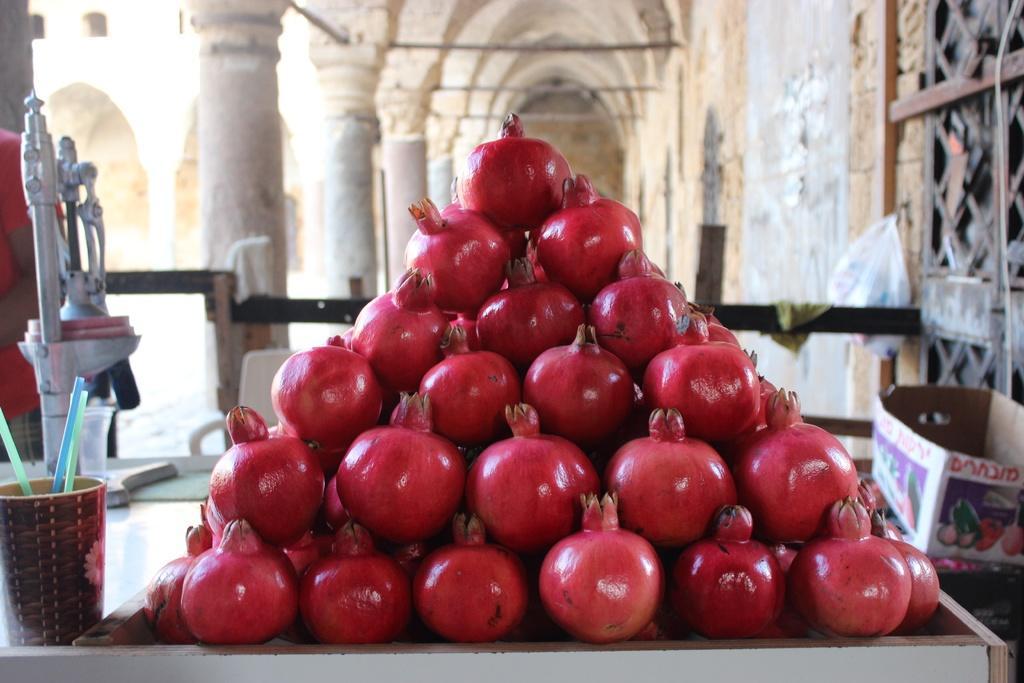How would you summarize this image in a sentence or two? In this picture I can see few pomegranates on the table and I can see a carton box on the side and few straws in the glass and I can see a machine and a polythene cover hanging to the nail. Picture shows inner view of a building. 